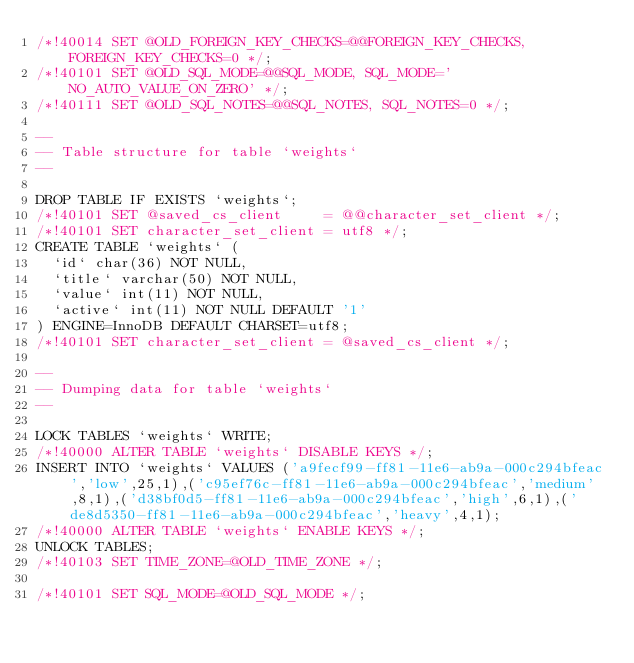Convert code to text. <code><loc_0><loc_0><loc_500><loc_500><_SQL_>/*!40014 SET @OLD_FOREIGN_KEY_CHECKS=@@FOREIGN_KEY_CHECKS, FOREIGN_KEY_CHECKS=0 */;
/*!40101 SET @OLD_SQL_MODE=@@SQL_MODE, SQL_MODE='NO_AUTO_VALUE_ON_ZERO' */;
/*!40111 SET @OLD_SQL_NOTES=@@SQL_NOTES, SQL_NOTES=0 */;

--
-- Table structure for table `weights`
--

DROP TABLE IF EXISTS `weights`;
/*!40101 SET @saved_cs_client     = @@character_set_client */;
/*!40101 SET character_set_client = utf8 */;
CREATE TABLE `weights` (
  `id` char(36) NOT NULL,
  `title` varchar(50) NOT NULL,
  `value` int(11) NOT NULL,
  `active` int(11) NOT NULL DEFAULT '1'
) ENGINE=InnoDB DEFAULT CHARSET=utf8;
/*!40101 SET character_set_client = @saved_cs_client */;

--
-- Dumping data for table `weights`
--

LOCK TABLES `weights` WRITE;
/*!40000 ALTER TABLE `weights` DISABLE KEYS */;
INSERT INTO `weights` VALUES ('a9fecf99-ff81-11e6-ab9a-000c294bfeac','low',25,1),('c95ef76c-ff81-11e6-ab9a-000c294bfeac','medium',8,1),('d38bf0d5-ff81-11e6-ab9a-000c294bfeac','high',6,1),('de8d5350-ff81-11e6-ab9a-000c294bfeac','heavy',4,1);
/*!40000 ALTER TABLE `weights` ENABLE KEYS */;
UNLOCK TABLES;
/*!40103 SET TIME_ZONE=@OLD_TIME_ZONE */;

/*!40101 SET SQL_MODE=@OLD_SQL_MODE */;</code> 